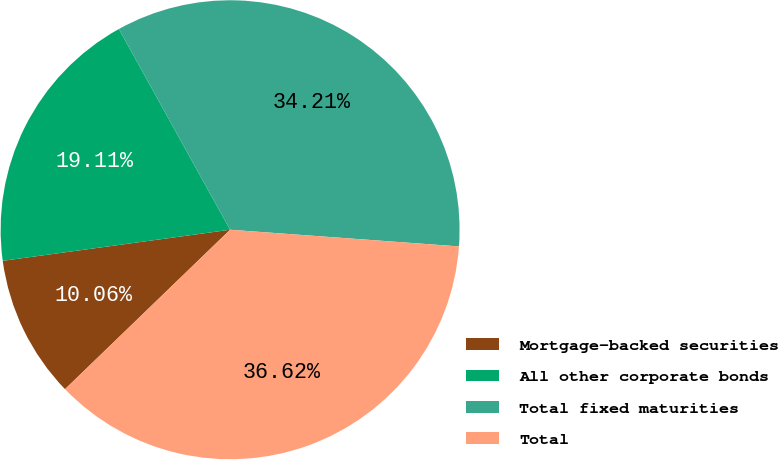Convert chart to OTSL. <chart><loc_0><loc_0><loc_500><loc_500><pie_chart><fcel>Mortgage-backed securities<fcel>All other corporate bonds<fcel>Total fixed maturities<fcel>Total<nl><fcel>10.06%<fcel>19.11%<fcel>34.21%<fcel>36.62%<nl></chart> 